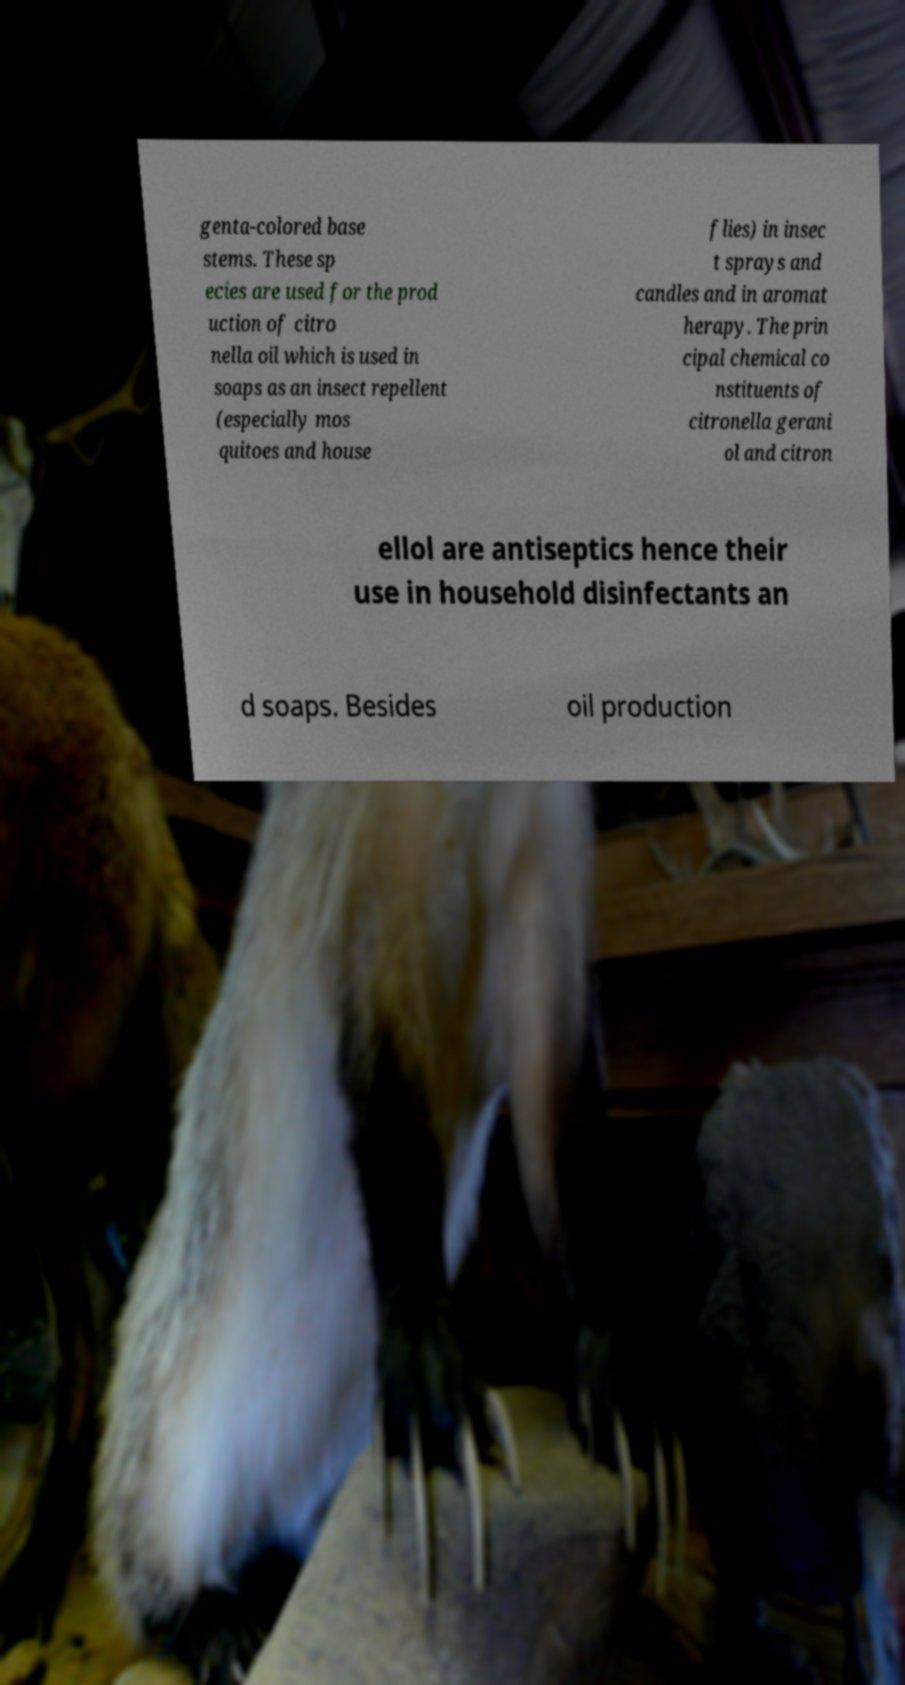What messages or text are displayed in this image? I need them in a readable, typed format. genta-colored base stems. These sp ecies are used for the prod uction of citro nella oil which is used in soaps as an insect repellent (especially mos quitoes and house flies) in insec t sprays and candles and in aromat herapy. The prin cipal chemical co nstituents of citronella gerani ol and citron ellol are antiseptics hence their use in household disinfectants an d soaps. Besides oil production 